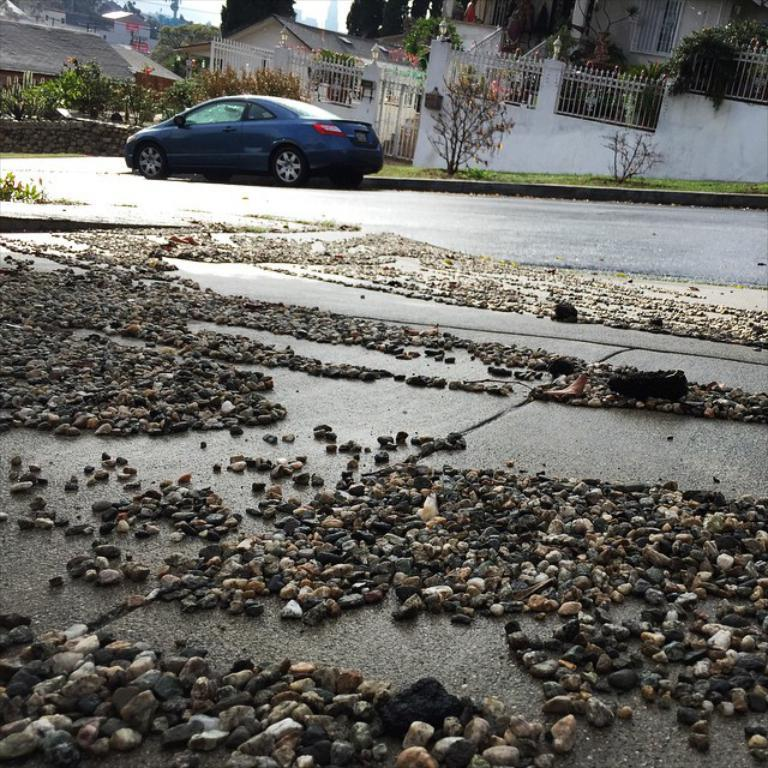What type of natural elements can be seen in the image? There are stones, grass, plants, trees, and the sky visible in the image. What man-made structures are present in the image? There is a fence, a wall, houses, and a car on the road in the image. What type of vegetation is present in the image? There are plants and trees in the image. How many houses can be seen in the image? There are houses in the image. What type of knife is being used to answer questions about the image? There is no knife present in the image, and no one is using a knife to answer questions about the image. 